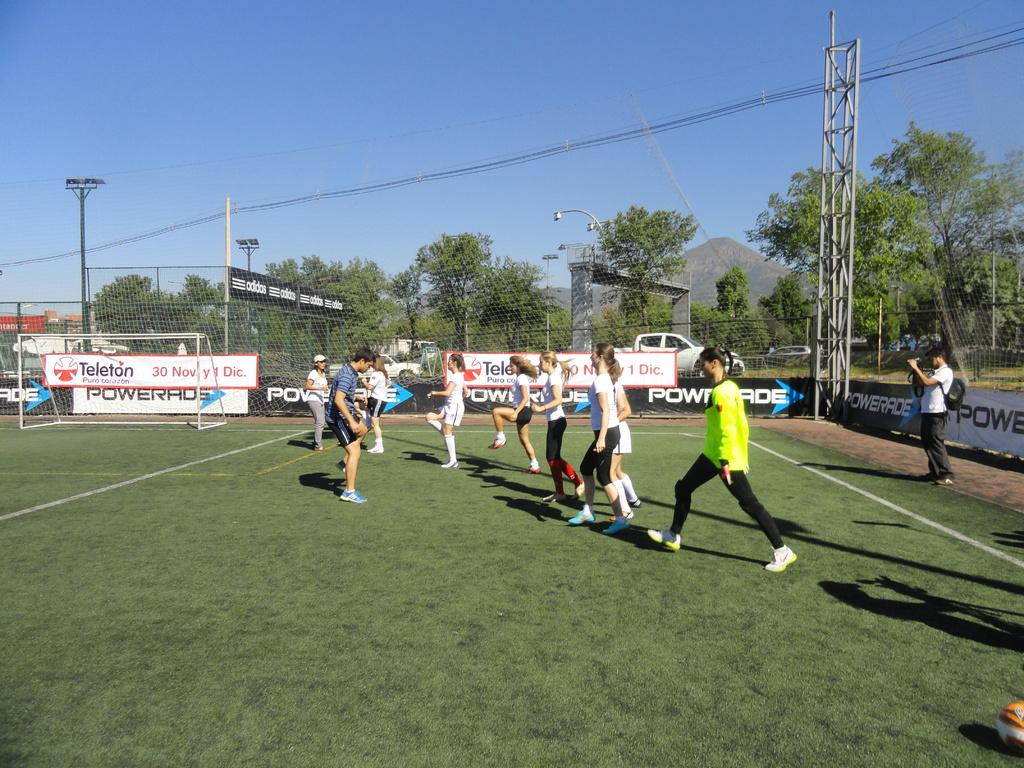<image>
Describe the image concisely. people doing exercises on a field in front of signs for Powerade 